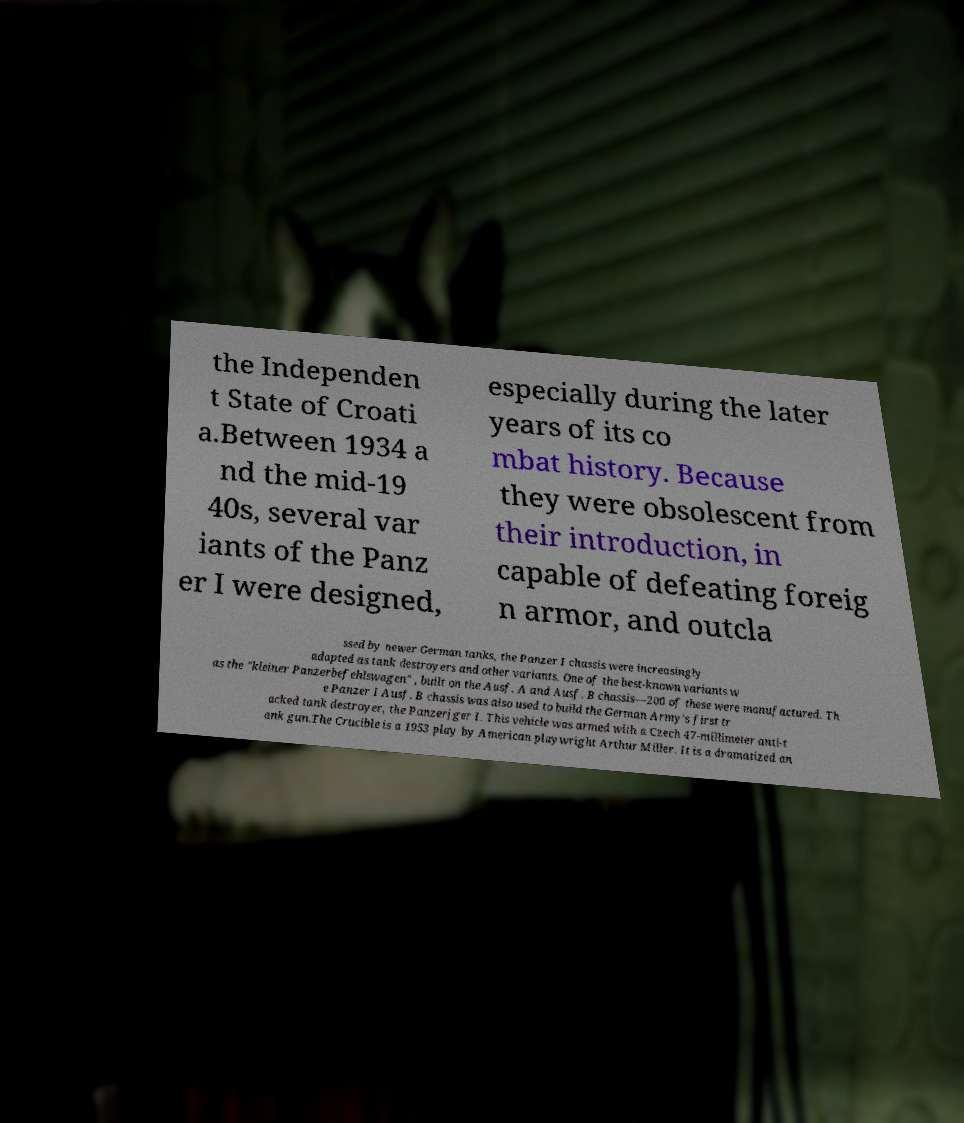Can you accurately transcribe the text from the provided image for me? the Independen t State of Croati a.Between 1934 a nd the mid-19 40s, several var iants of the Panz er I were designed, especially during the later years of its co mbat history. Because they were obsolescent from their introduction, in capable of defeating foreig n armor, and outcla ssed by newer German tanks, the Panzer I chassis were increasingly adapted as tank destroyers and other variants. One of the best-known variants w as the "kleiner Panzerbefehlswagen" , built on the Ausf. A and Ausf. B chassis—200 of these were manufactured. Th e Panzer I Ausf. B chassis was also used to build the German Army's first tr acked tank destroyer, the Panzerjger I. This vehicle was armed with a Czech 47-millimeter anti-t ank gun.The Crucible is a 1953 play by American playwright Arthur Miller. It is a dramatized an 